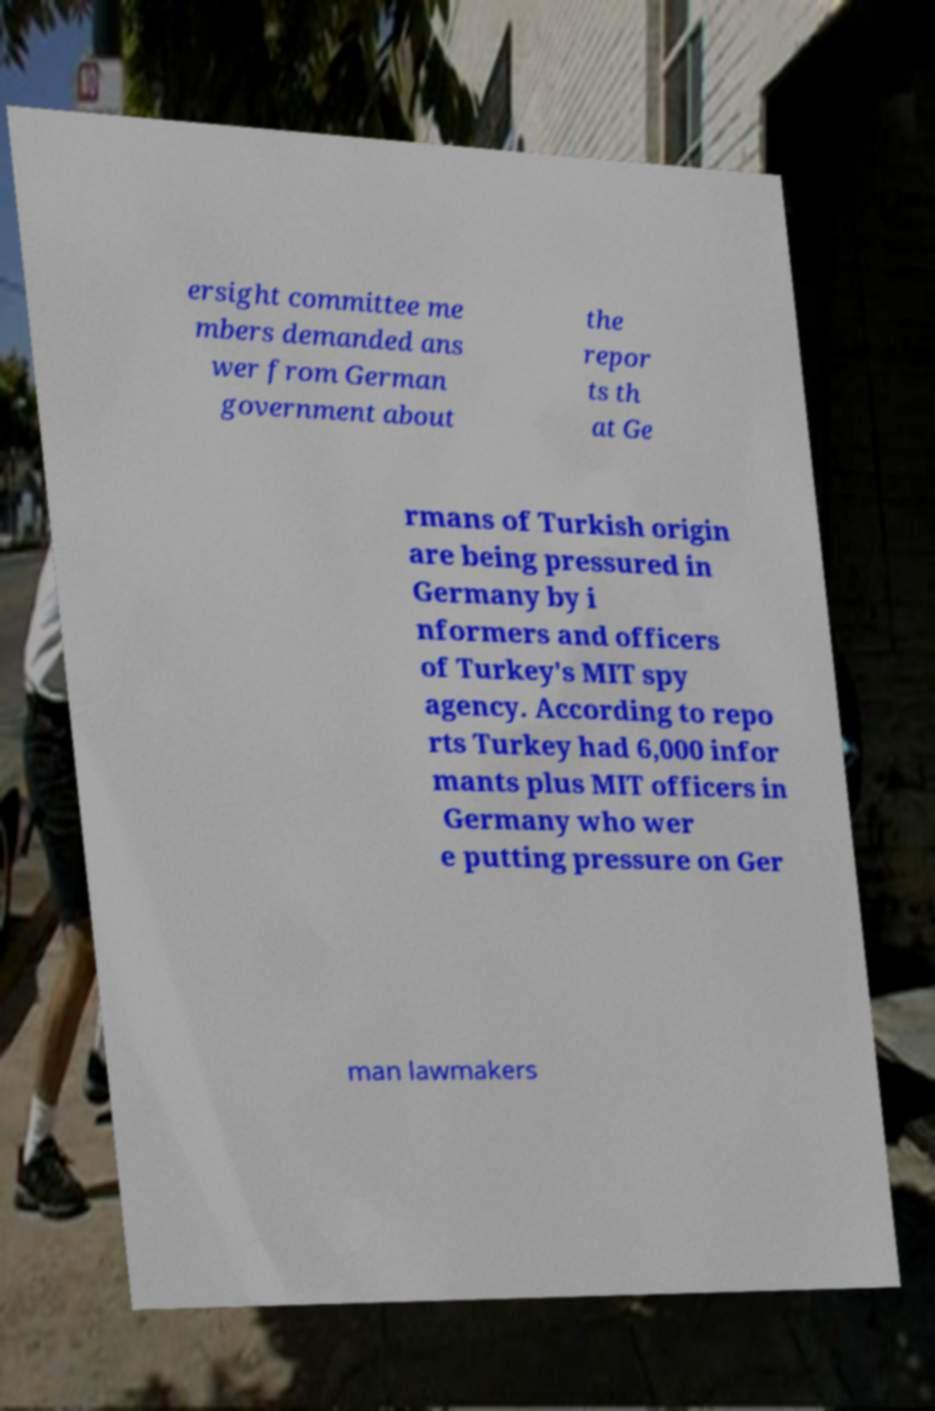Could you assist in decoding the text presented in this image and type it out clearly? ersight committee me mbers demanded ans wer from German government about the repor ts th at Ge rmans of Turkish origin are being pressured in Germany by i nformers and officers of Turkey's MIT spy agency. According to repo rts Turkey had 6,000 infor mants plus MIT officers in Germany who wer e putting pressure on Ger man lawmakers 